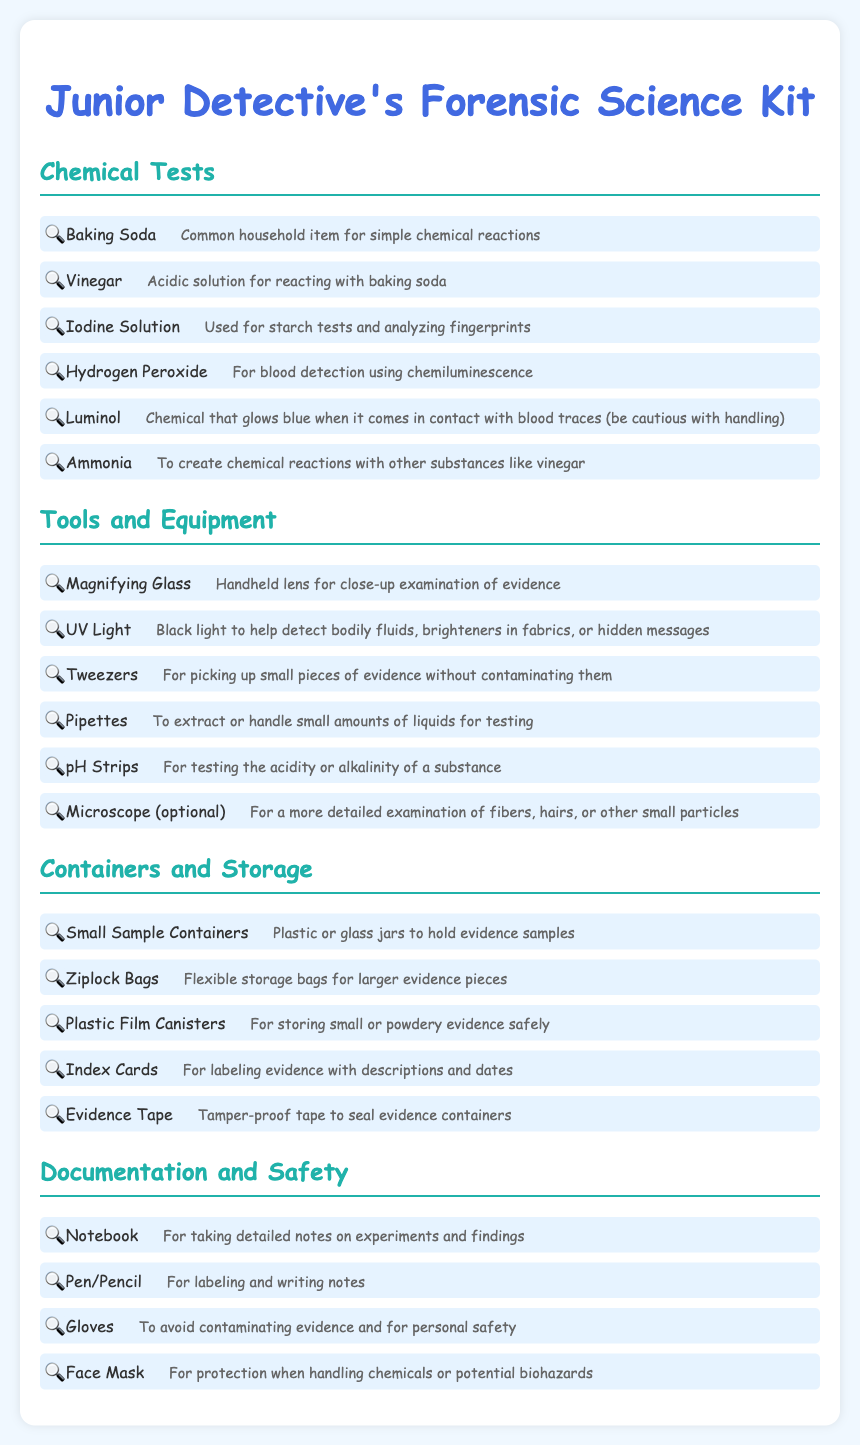What is the title of the document? The title of the document is presented prominently at the top of the rendered page.
Answer: Junior Detective's Forensic Science Kit How many chemical tests are listed? The document presents a list of chemical tests in a specific section, and counting those gives the total.
Answer: 6 What item is used for close-up examination of evidence? This tool is explicitly mentioned in the tools and equipment section for that purpose.
Answer: Magnifying Glass What is the purpose of a UV light? The document describes the specific uses for the UV light in detail within the tools and equipment section.
Answer: Detect bodily fluids What should be used to avoid contaminating evidence? The document specifies a particular item that helps ensure evidence remains uncontaminated.
Answer: Gloves What type of bags should be used for larger evidence pieces? This item is mentioned explicitly in the containers and storage section as suitable for larger items.
Answer: Ziplock Bags How many items are listed under documentation and safety? This can be determined by counting the items specifically listed in that section of the document.
Answer: 4 What is used for labeling evidence with descriptions? The document explicitly identifies an item with this functionality in the storage section.
Answer: Index Cards Name one chemical that glows blue when in contact with blood traces. This is mentioned in the chemical tests section, describing its unique property.
Answer: Luminol 